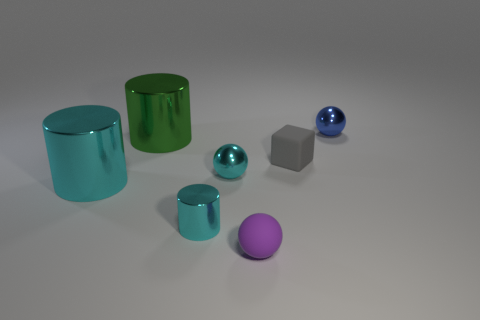Are there any other things that are the same shape as the gray matte object?
Provide a short and direct response. No. What number of green metal objects have the same size as the purple matte ball?
Offer a terse response. 0. There is a large metallic object behind the gray cube; is its shape the same as the cyan object that is to the left of the big green metal cylinder?
Keep it short and to the point. Yes. There is a large shiny thing that is the same color as the small cylinder; what shape is it?
Keep it short and to the point. Cylinder. There is a shiny cylinder that is behind the small shiny ball that is to the left of the blue metallic sphere; what color is it?
Your response must be concise. Green. What is the color of the other big metal thing that is the same shape as the green metal object?
Offer a very short reply. Cyan. Are there any other things that are the same material as the purple thing?
Give a very brief answer. Yes. What size is the green thing that is the same shape as the big cyan metallic object?
Make the answer very short. Large. There is a ball to the left of the purple matte thing; what is its material?
Provide a short and direct response. Metal. Are there fewer blue metal balls left of the tiny cyan metallic ball than large blue balls?
Keep it short and to the point. No. 